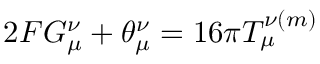Convert formula to latex. <formula><loc_0><loc_0><loc_500><loc_500>2 F G _ { \mu } ^ { \nu } + \theta _ { \mu } ^ { \nu } = 1 6 \pi T _ { \mu } ^ { \nu ( m ) }</formula> 